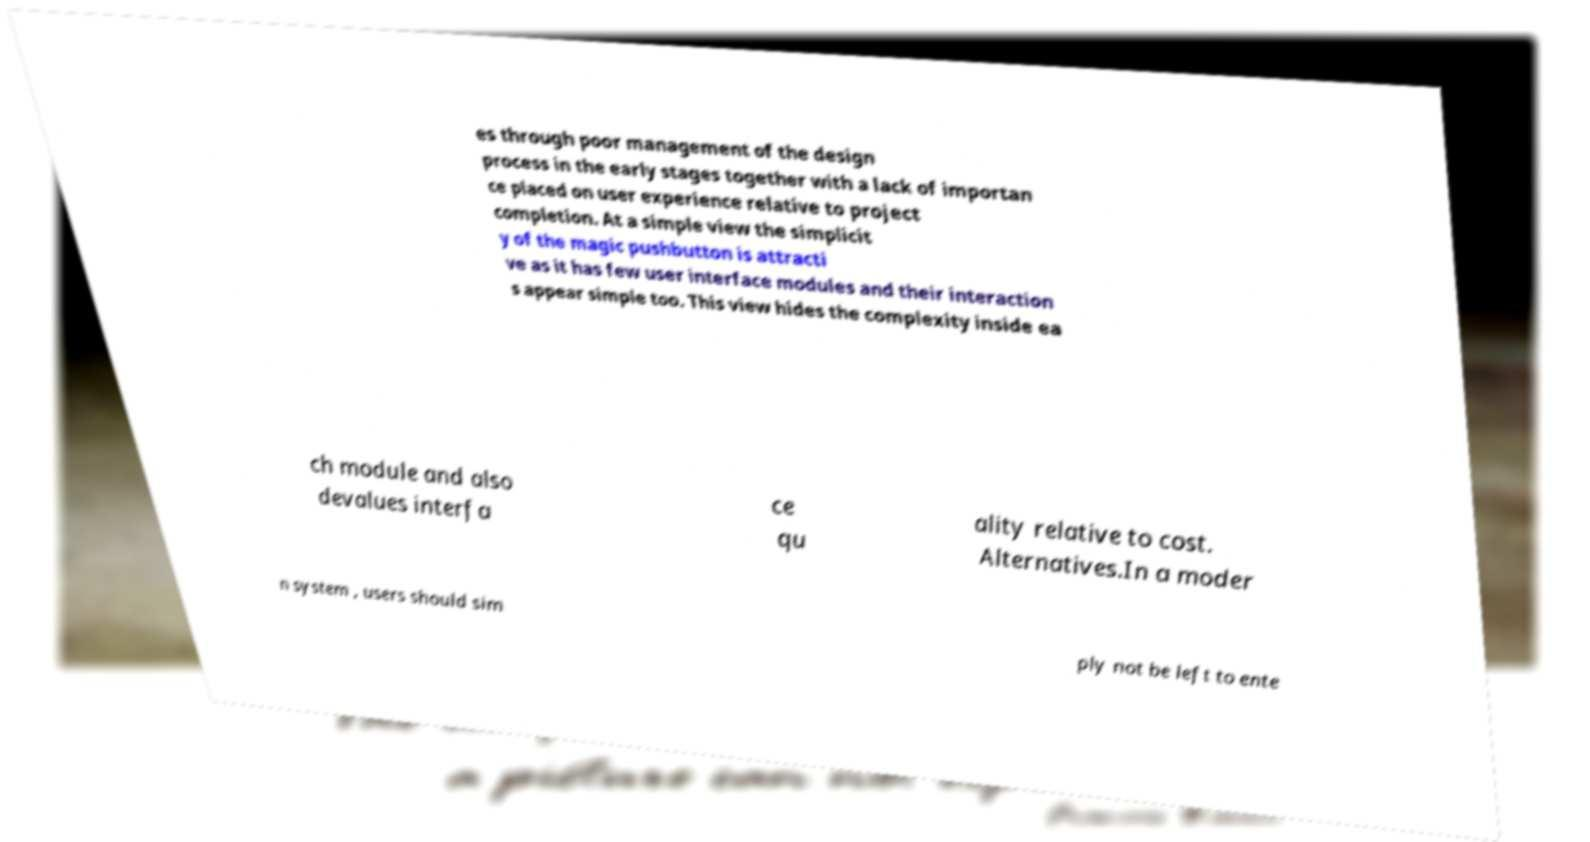What messages or text are displayed in this image? I need them in a readable, typed format. es through poor management of the design process in the early stages together with a lack of importan ce placed on user experience relative to project completion. At a simple view the simplicit y of the magic pushbutton is attracti ve as it has few user interface modules and their interaction s appear simple too. This view hides the complexity inside ea ch module and also devalues interfa ce qu ality relative to cost. Alternatives.In a moder n system , users should sim ply not be left to ente 